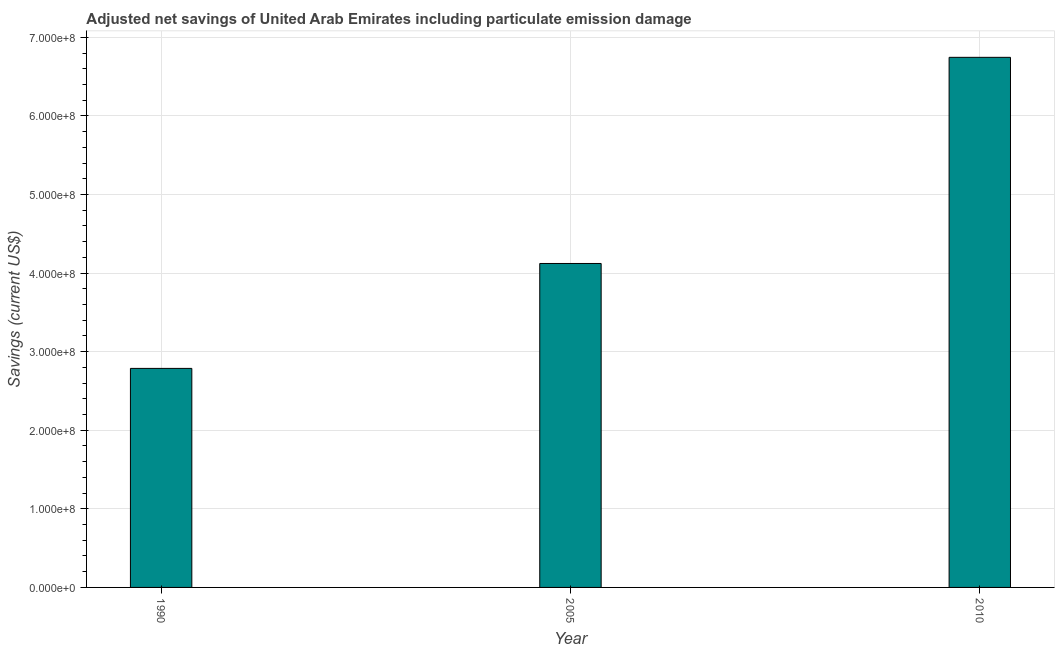Does the graph contain any zero values?
Give a very brief answer. No. What is the title of the graph?
Make the answer very short. Adjusted net savings of United Arab Emirates including particulate emission damage. What is the label or title of the Y-axis?
Your answer should be very brief. Savings (current US$). What is the adjusted net savings in 1990?
Make the answer very short. 2.79e+08. Across all years, what is the maximum adjusted net savings?
Provide a short and direct response. 6.75e+08. Across all years, what is the minimum adjusted net savings?
Offer a very short reply. 2.79e+08. In which year was the adjusted net savings minimum?
Offer a very short reply. 1990. What is the sum of the adjusted net savings?
Provide a short and direct response. 1.37e+09. What is the difference between the adjusted net savings in 1990 and 2010?
Offer a terse response. -3.96e+08. What is the average adjusted net savings per year?
Your answer should be very brief. 4.55e+08. What is the median adjusted net savings?
Offer a terse response. 4.12e+08. Do a majority of the years between 1990 and 2005 (inclusive) have adjusted net savings greater than 260000000 US$?
Your answer should be compact. Yes. What is the ratio of the adjusted net savings in 1990 to that in 2005?
Provide a succinct answer. 0.68. Is the difference between the adjusted net savings in 1990 and 2005 greater than the difference between any two years?
Offer a terse response. No. What is the difference between the highest and the second highest adjusted net savings?
Provide a succinct answer. 2.62e+08. Is the sum of the adjusted net savings in 2005 and 2010 greater than the maximum adjusted net savings across all years?
Offer a terse response. Yes. What is the difference between the highest and the lowest adjusted net savings?
Keep it short and to the point. 3.96e+08. In how many years, is the adjusted net savings greater than the average adjusted net savings taken over all years?
Provide a succinct answer. 1. Are all the bars in the graph horizontal?
Keep it short and to the point. No. What is the difference between two consecutive major ticks on the Y-axis?
Offer a terse response. 1.00e+08. Are the values on the major ticks of Y-axis written in scientific E-notation?
Give a very brief answer. Yes. What is the Savings (current US$) in 1990?
Ensure brevity in your answer.  2.79e+08. What is the Savings (current US$) in 2005?
Make the answer very short. 4.12e+08. What is the Savings (current US$) of 2010?
Give a very brief answer. 6.75e+08. What is the difference between the Savings (current US$) in 1990 and 2005?
Your response must be concise. -1.34e+08. What is the difference between the Savings (current US$) in 1990 and 2010?
Your response must be concise. -3.96e+08. What is the difference between the Savings (current US$) in 2005 and 2010?
Your answer should be very brief. -2.62e+08. What is the ratio of the Savings (current US$) in 1990 to that in 2005?
Your answer should be very brief. 0.68. What is the ratio of the Savings (current US$) in 1990 to that in 2010?
Ensure brevity in your answer.  0.41. What is the ratio of the Savings (current US$) in 2005 to that in 2010?
Your answer should be compact. 0.61. 